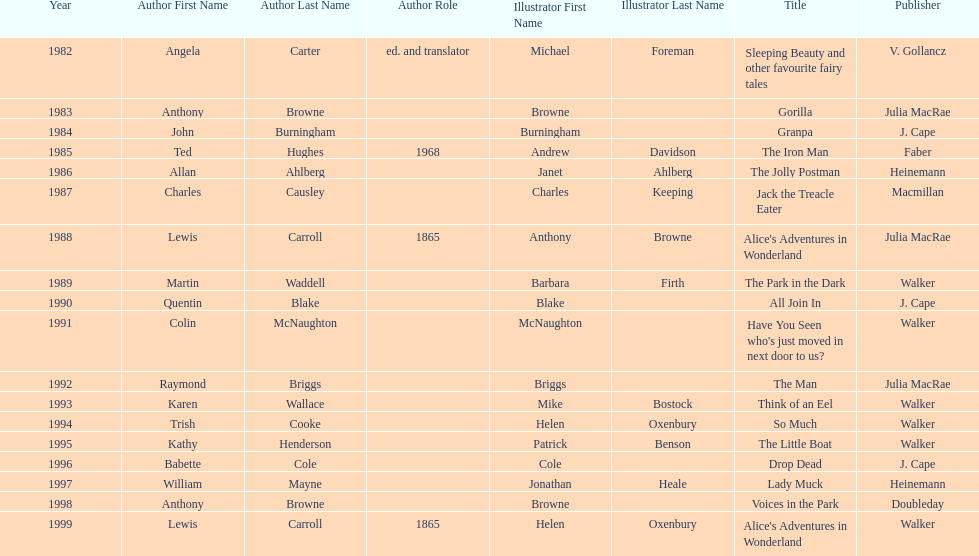What's the difference in years between angela carter's title and anthony browne's? 1. 